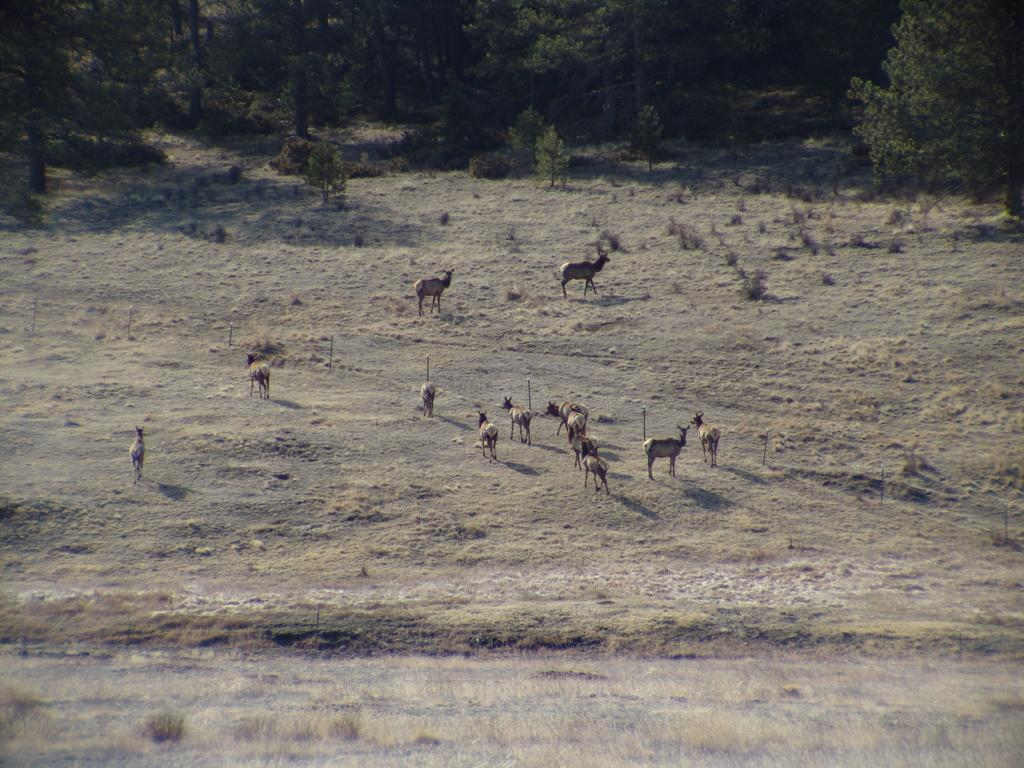What types of living organisms are in the image? There are animals in the image. What is the surface on which the animals are standing? The animals are standing on the ground. What type of vegetation is present in the image? Grass is present in the image. What other natural elements can be seen in the image? There are trees in the image. What type of manager is overseeing the animals in the image? There is no manager present in the image; it only features animals standing on the ground. What type of space is visible in the image? The image does not depict any space; it is set on the ground with grass and trees. 